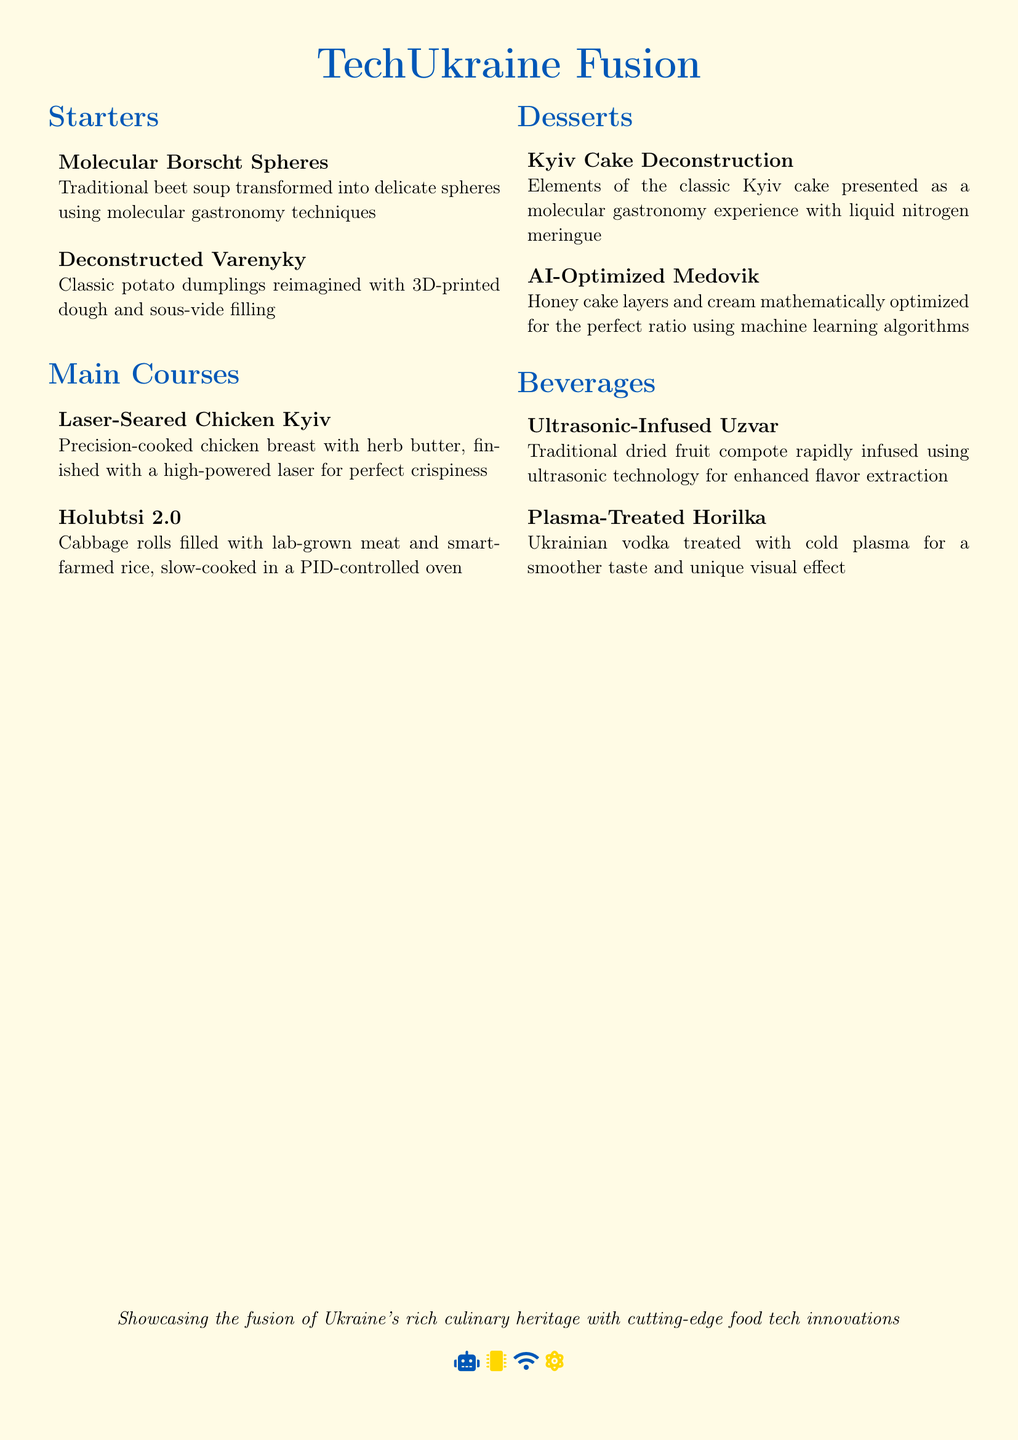What is the name of the restaurant? The name of the restaurant is found in the title at the top of the document.
Answer: TechUkraine Fusion How many main courses are listed? The number of main courses is determined by counting the items under the Main Courses section.
Answer: Two What cooking technique is used for the Molecular Borscht Spheres? The technique used for the Molecular Borscht Spheres is mentioned in the description of the dish.
Answer: Molecular gastronomy What type of meat is used in Holubtsi 2.0? The meat type for Holubtsi 2.0 is specified in the dish description.
Answer: Lab-grown meat Which dessert features liquid nitrogen? The dessert name that mentions liquid nitrogen is indicated in its description.
Answer: Kyiv Cake Deconstruction What is the purpose of ultrasonic technology in the beverages section? The purpose is described in the context of enhancing flavor extraction for a certain beverage.
Answer: Flavor extraction What ingredient is optimized in the AI-Optimized Medovik? The ingredient optimized in the dessert is described in the dish's explanation.
Answer: Honey cake layers and cream What is used to treat the Plasma-Treated Horilka? The treatment method for the horilka is specified in the beverage description.
Answer: Cold plasma 